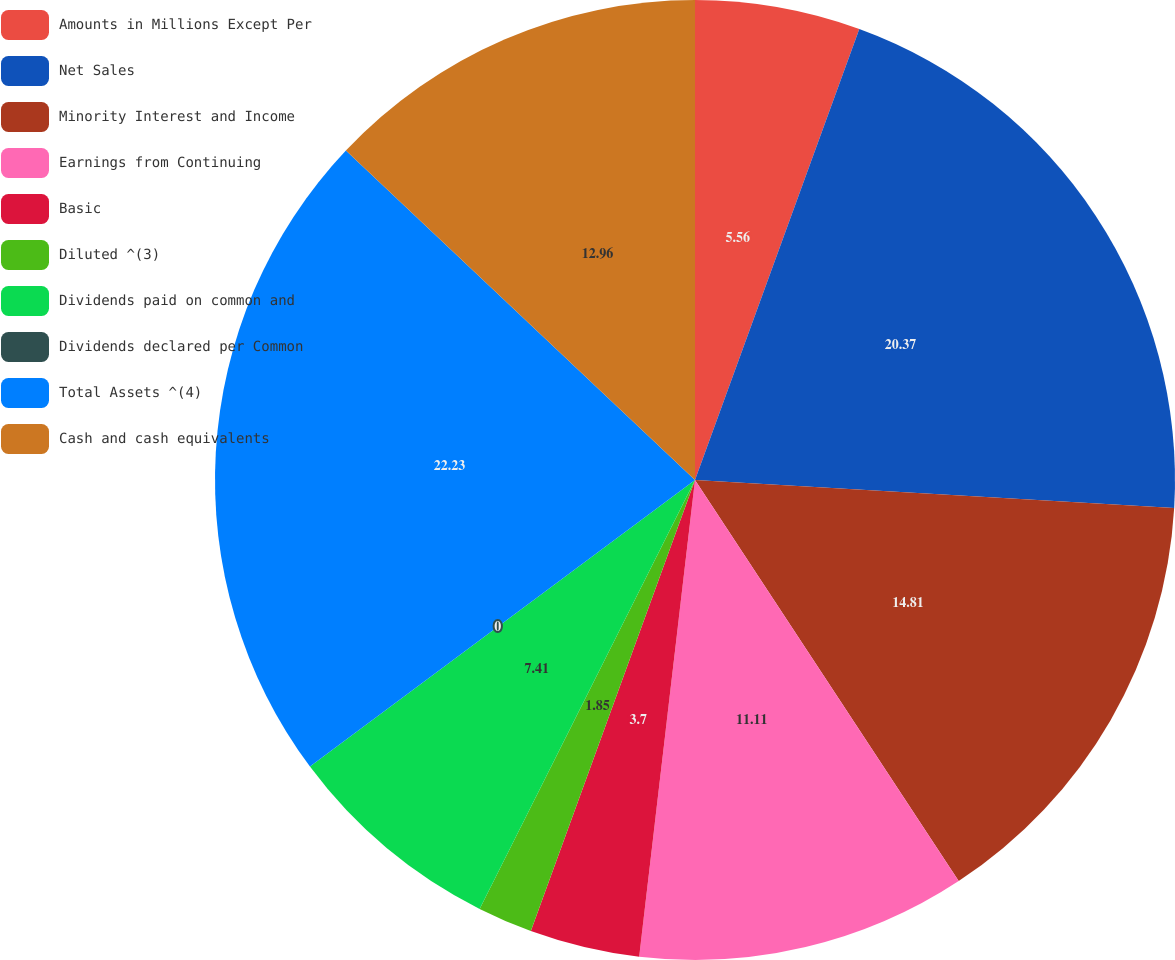Convert chart to OTSL. <chart><loc_0><loc_0><loc_500><loc_500><pie_chart><fcel>Amounts in Millions Except Per<fcel>Net Sales<fcel>Minority Interest and Income<fcel>Earnings from Continuing<fcel>Basic<fcel>Diluted ^(3)<fcel>Dividends paid on common and<fcel>Dividends declared per Common<fcel>Total Assets ^(4)<fcel>Cash and cash equivalents<nl><fcel>5.56%<fcel>20.37%<fcel>14.81%<fcel>11.11%<fcel>3.7%<fcel>1.85%<fcel>7.41%<fcel>0.0%<fcel>22.22%<fcel>12.96%<nl></chart> 